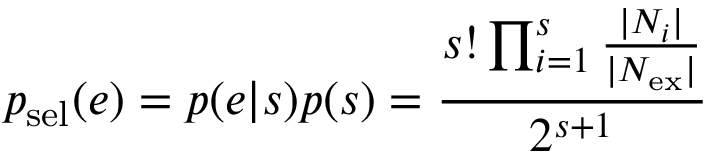<formula> <loc_0><loc_0><loc_500><loc_500>p _ { s e l } ( e ) = p ( e | s ) p ( s ) = \frac { s ! \prod _ { i = 1 } ^ { s } \frac { | N _ { i } | } { | N _ { e x } | } } { 2 ^ { s + 1 } }</formula> 